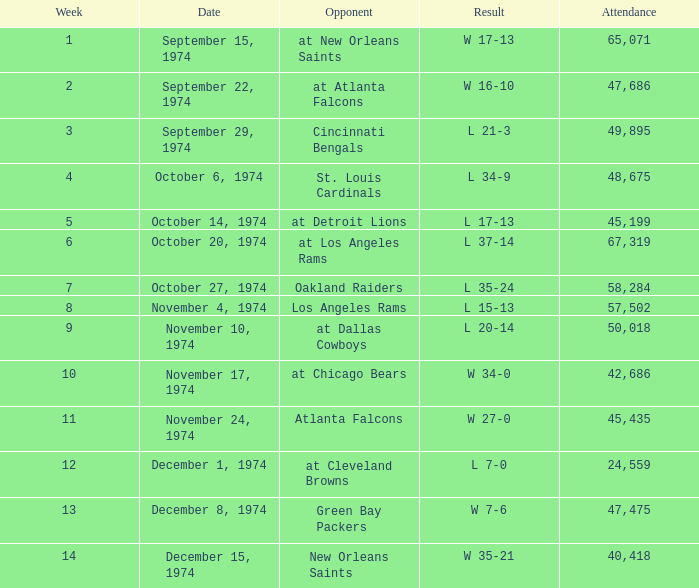What was the result before week 13 when they played the Oakland Raiders? L 35-24. 